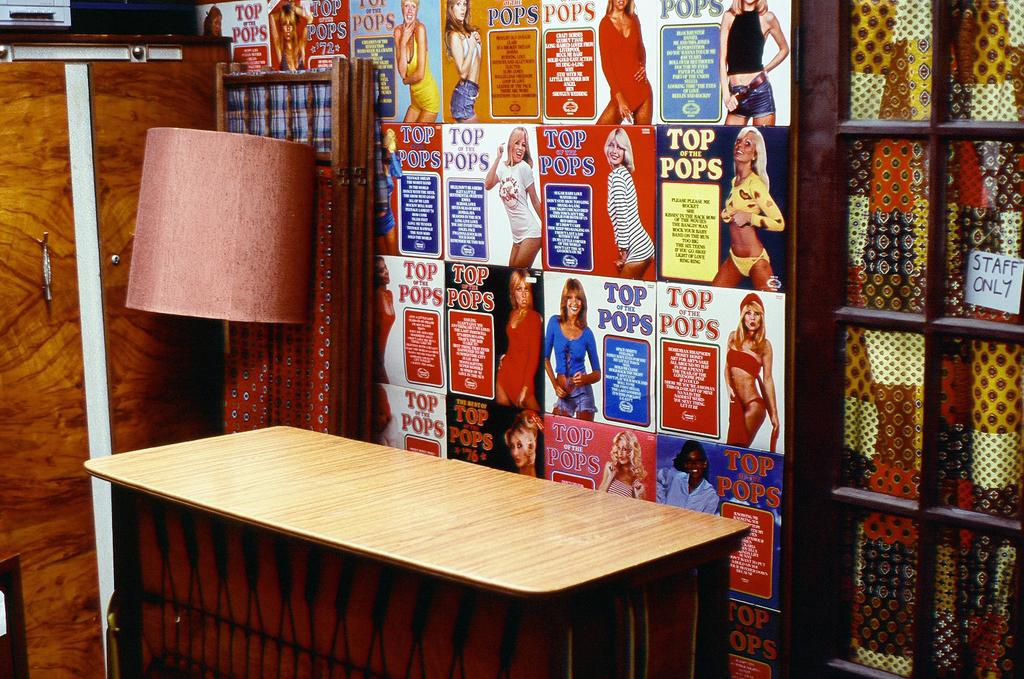<image>
Summarize the visual content of the image. A wall covered in Top of the Pops magazine covers and some other retro decor. 